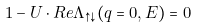<formula> <loc_0><loc_0><loc_500><loc_500>1 - U \cdot { R e } \Lambda _ { \uparrow \downarrow } ( { q } = 0 , E ) = 0</formula> 